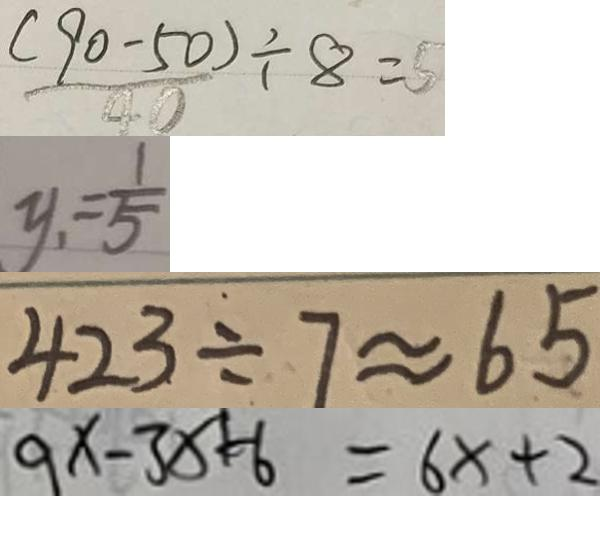<formula> <loc_0><loc_0><loc_500><loc_500>\frac { ( 9 0 - 5 0 ) } { 4 0 } \div 8 = 5 
 y _ { 1 } = \frac { 1 } { 5 } 
 4 2 3 \div 7 \approx 6 5 
 9 x - 3 x = 6 x + 2</formula> 